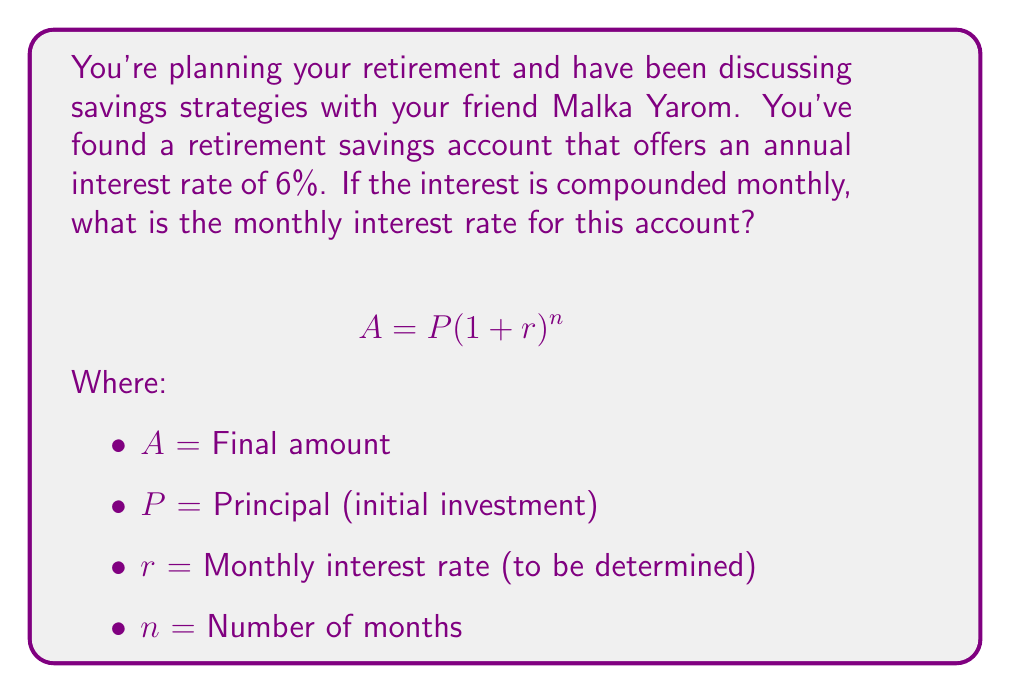What is the answer to this math problem? To solve this problem, we need to convert the annual interest rate to a monthly rate. Here's how we do it:

1) The given annual interest rate is 6% or 0.06.

2) We know that compound interest formula is:
   $$A = P(1 + r)^n$$

3) For annual compounding, this would be:
   $$A = P(1 + 0.06)^1$$

4) For monthly compounding, we need to find r such that:
   $$(1 + r)^{12} = 1 + 0.06$$

5) Solving for r:
   $$r = (1 + 0.06)^{\frac{1}{12}} - 1$$

6) Calculate:
   $$r = (1.06)^{\frac{1}{12}} - 1$$
   $$r \approx 1.004868 - 1$$
   $$r \approx 0.004868$$

7) Convert to a percentage:
   $$r \approx 0.4868\%$$

Therefore, the monthly interest rate is approximately 0.4868%.
Answer: 0.4868% 